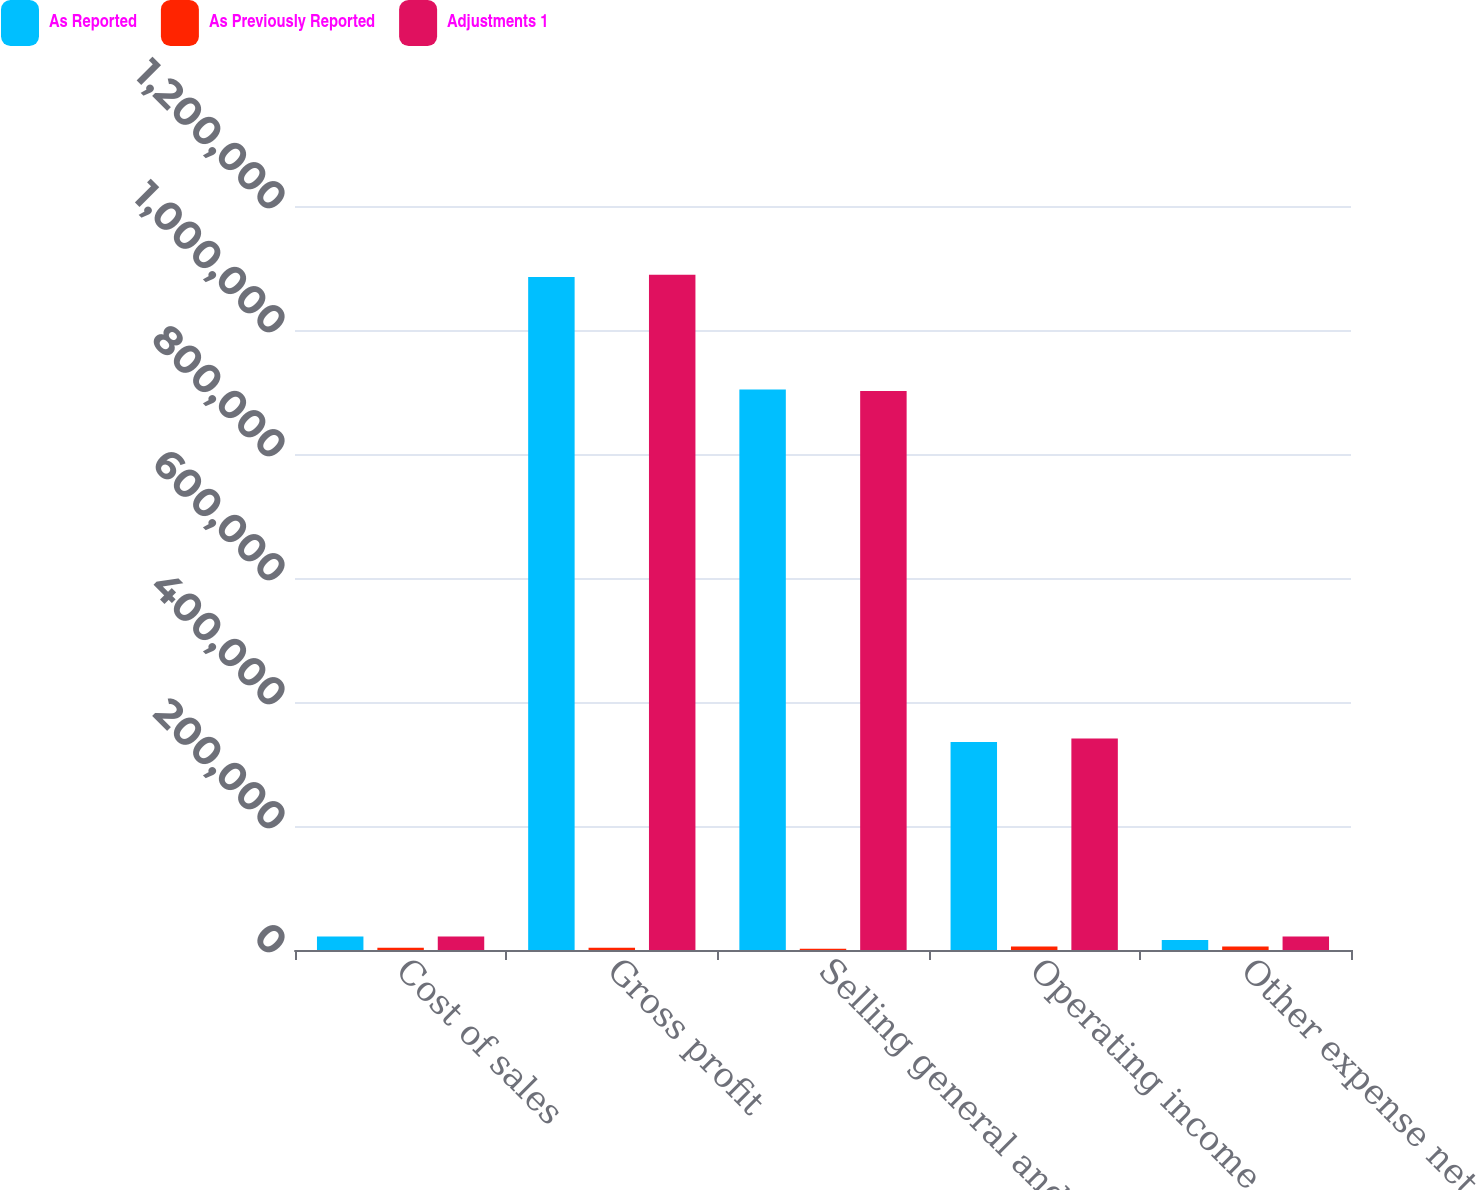Convert chart. <chart><loc_0><loc_0><loc_500><loc_500><stacked_bar_chart><ecel><fcel>Cost of sales<fcel>Gross profit<fcel>Selling general and<fcel>Operating income<fcel>Other expense net<nl><fcel>As Reported<fcel>21827<fcel>1.08538e+06<fcel>903864<fcel>335422<fcel>16114<nl><fcel>As Previously Reported<fcel>3576<fcel>3576<fcel>2137<fcel>5713<fcel>5713<nl><fcel>Adjustments 1<fcel>21827<fcel>1.08895e+06<fcel>901727<fcel>341135<fcel>21827<nl></chart> 